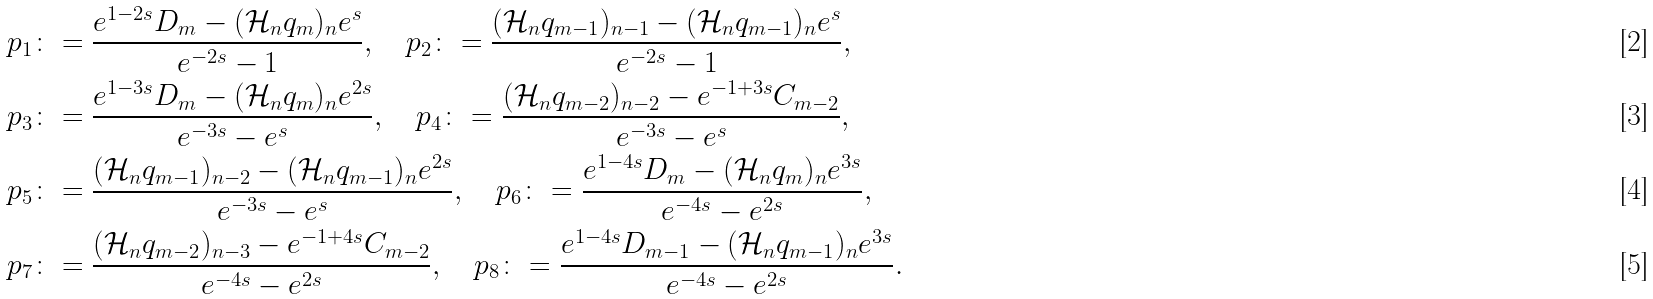<formula> <loc_0><loc_0><loc_500><loc_500>p _ { 1 } & \colon = \frac { e ^ { 1 - 2 s } D _ { m } - ( \mathcal { H } _ { n } q _ { m } ) _ { n } e ^ { s } } { e ^ { - 2 s } - 1 } , \quad p _ { 2 } \colon = \frac { ( \mathcal { H } _ { n } q _ { m - 1 } ) _ { n - 1 } - ( \mathcal { H } _ { n } q _ { m - 1 } ) _ { n } e ^ { s } } { e ^ { - 2 s } - 1 } , \\ p _ { 3 } & \colon = \frac { e ^ { 1 - 3 s } D _ { m } - ( \mathcal { H } _ { n } q _ { m } ) _ { n } e ^ { 2 s } } { e ^ { - 3 s } - e ^ { s } } , \quad p _ { 4 } \colon = \frac { ( \mathcal { H } _ { n } q _ { m - 2 } ) _ { n - 2 } - e ^ { - 1 + 3 s } C _ { m - 2 } } { e ^ { - 3 s } - e ^ { s } } , \\ p _ { 5 } & \colon = \frac { ( \mathcal { H } _ { n } q _ { m - 1 } ) _ { n - 2 } - ( \mathcal { H } _ { n } q _ { m - 1 } ) _ { n } e ^ { 2 s } } { e ^ { - 3 s } - e ^ { s } } , \quad p _ { 6 } \colon = \frac { e ^ { 1 - 4 s } D _ { m } - ( \mathcal { H } _ { n } q _ { m } ) _ { n } e ^ { 3 s } } { e ^ { - 4 s } - e ^ { 2 s } } , \\ p _ { 7 } & \colon = \frac { ( \mathcal { H } _ { n } q _ { m - 2 } ) _ { n - 3 } - e ^ { - 1 + 4 s } C _ { m - 2 } } { e ^ { - 4 s } - e ^ { 2 s } } , \quad p _ { 8 } \colon = \frac { e ^ { 1 - 4 s } D _ { m - 1 } - ( \mathcal { H } _ { n } q _ { m - 1 } ) _ { n } e ^ { 3 s } } { e ^ { - 4 s } - e ^ { 2 s } } .</formula> 